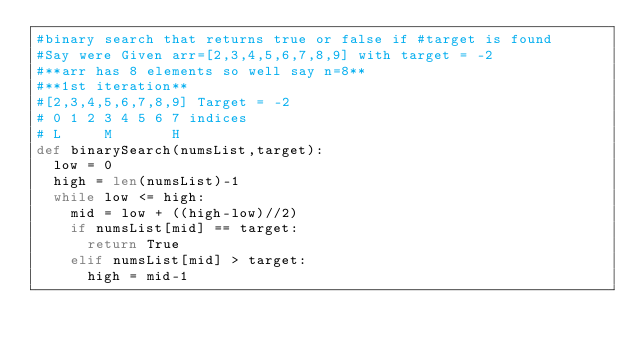Convert code to text. <code><loc_0><loc_0><loc_500><loc_500><_Python_>#binary search that returns true or false if #target is found
#Say were Given arr=[2,3,4,5,6,7,8,9] with target = -2
#**arr has 8 elements so well say n=8**
#**1st iteration**
#[2,3,4,5,6,7,8,9] Target = -2
# 0 1 2 3 4 5 6 7 indices
# L     M       H 
def binarySearch(numsList,target):
  low = 0
  high = len(numsList)-1
  while low <= high:
    mid = low + ((high-low)//2)
    if numsList[mid] == target:
      return True
    elif numsList[mid] > target:
      high = mid-1</code> 